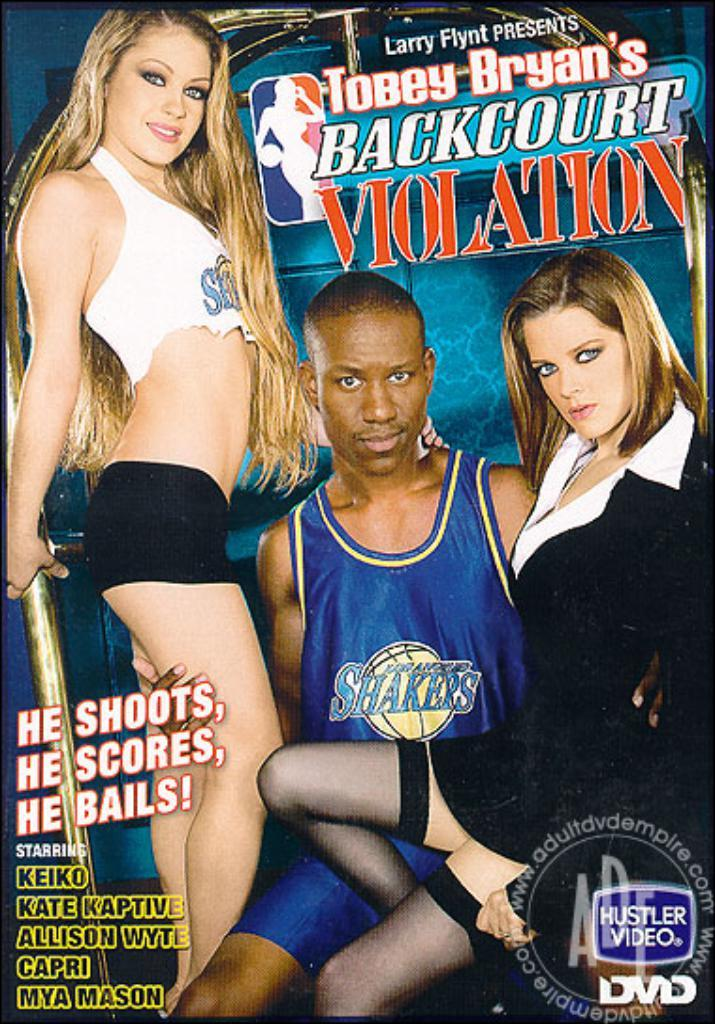<image>
Provide a brief description of the given image. An advertisement for Backcourt Violation that has a picture of a man and two ladies. 